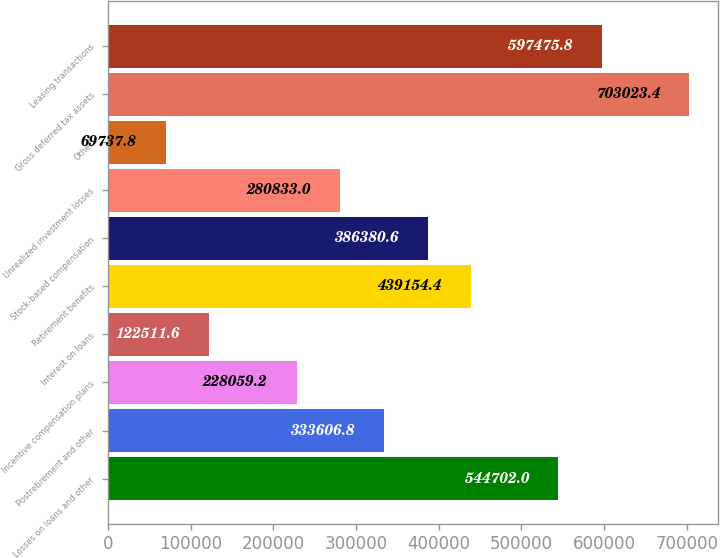Convert chart to OTSL. <chart><loc_0><loc_0><loc_500><loc_500><bar_chart><fcel>Losses on loans and other<fcel>Postretirement and other<fcel>Incentive compensation plans<fcel>Interest on loans<fcel>Retirement benefits<fcel>Stock-based compensation<fcel>Unrealized investment losses<fcel>Other<fcel>Gross deferred tax assets<fcel>Leasing transactions<nl><fcel>544702<fcel>333607<fcel>228059<fcel>122512<fcel>439154<fcel>386381<fcel>280833<fcel>69737.8<fcel>703023<fcel>597476<nl></chart> 